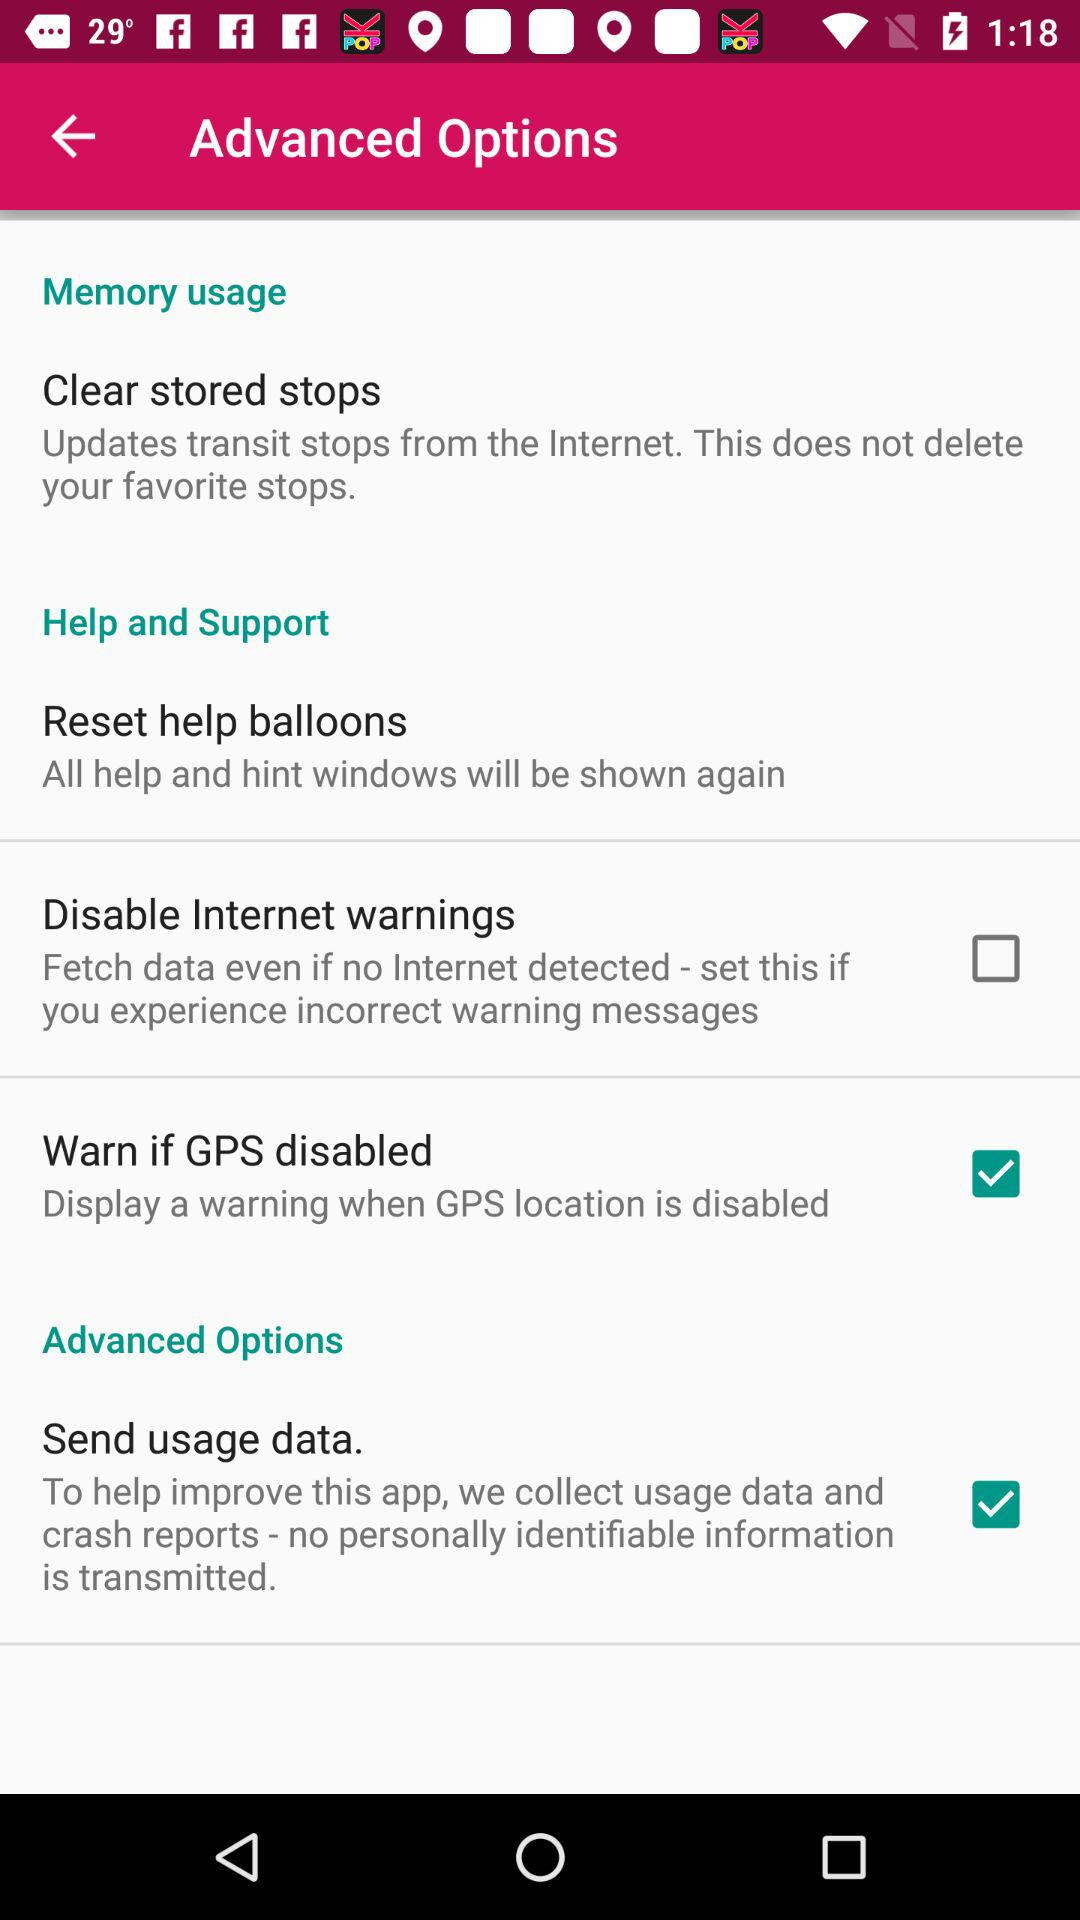What is the status of "Send usage data" in "Advanced Options"? The status is "on". 